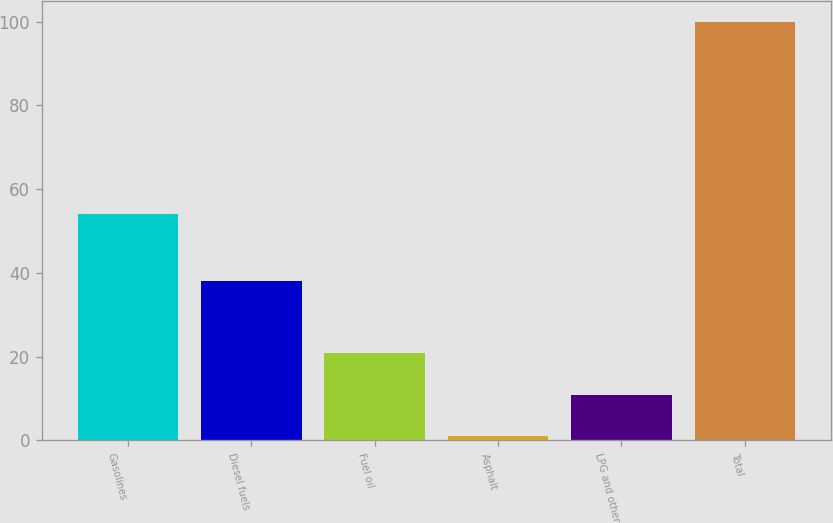Convert chart. <chart><loc_0><loc_0><loc_500><loc_500><bar_chart><fcel>Gasolines<fcel>Diesel fuels<fcel>Fuel oil<fcel>Asphalt<fcel>LPG and other<fcel>Total<nl><fcel>54<fcel>38<fcel>20.8<fcel>1<fcel>10.9<fcel>100<nl></chart> 